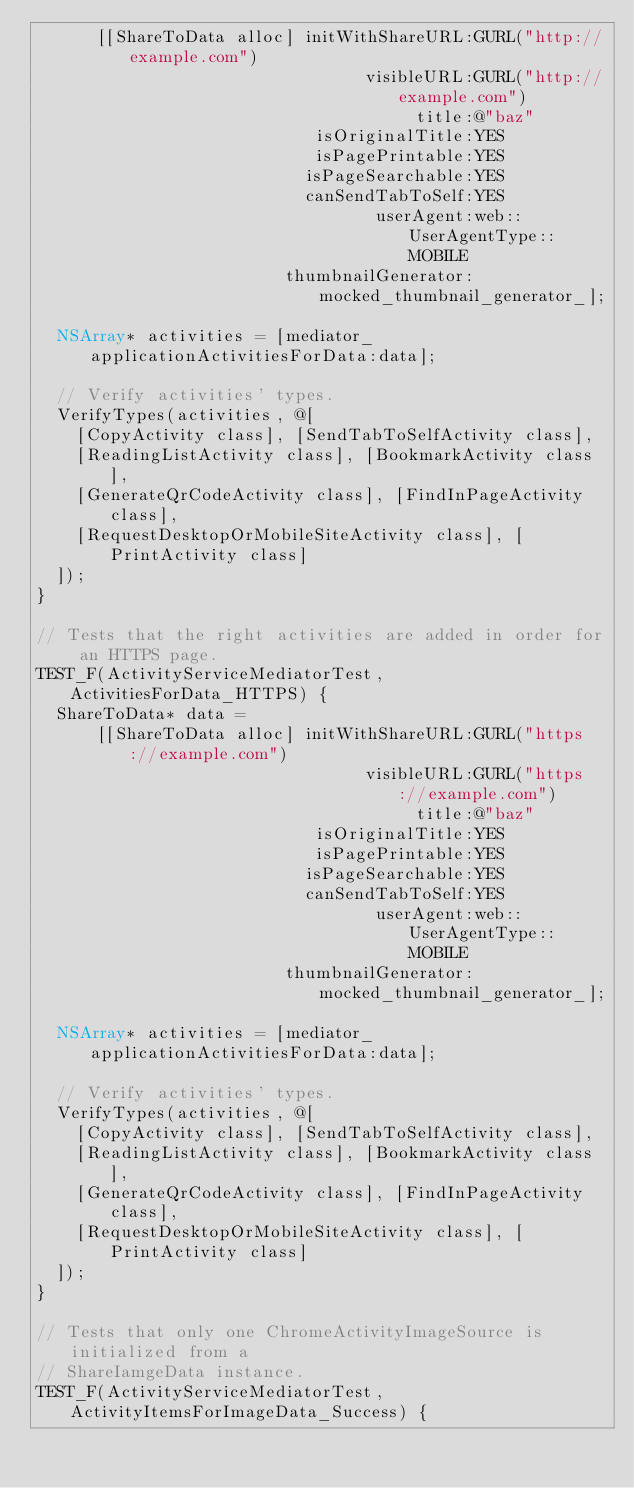Convert code to text. <code><loc_0><loc_0><loc_500><loc_500><_ObjectiveC_>      [[ShareToData alloc] initWithShareURL:GURL("http://example.com")
                                 visibleURL:GURL("http://example.com")
                                      title:@"baz"
                            isOriginalTitle:YES
                            isPagePrintable:YES
                           isPageSearchable:YES
                           canSendTabToSelf:YES
                                  userAgent:web::UserAgentType::MOBILE
                         thumbnailGenerator:mocked_thumbnail_generator_];

  NSArray* activities = [mediator_ applicationActivitiesForData:data];

  // Verify activities' types.
  VerifyTypes(activities, @[
    [CopyActivity class], [SendTabToSelfActivity class],
    [ReadingListActivity class], [BookmarkActivity class],
    [GenerateQrCodeActivity class], [FindInPageActivity class],
    [RequestDesktopOrMobileSiteActivity class], [PrintActivity class]
  ]);
}

// Tests that the right activities are added in order for an HTTPS page.
TEST_F(ActivityServiceMediatorTest, ActivitiesForData_HTTPS) {
  ShareToData* data =
      [[ShareToData alloc] initWithShareURL:GURL("https://example.com")
                                 visibleURL:GURL("https://example.com")
                                      title:@"baz"
                            isOriginalTitle:YES
                            isPagePrintable:YES
                           isPageSearchable:YES
                           canSendTabToSelf:YES
                                  userAgent:web::UserAgentType::MOBILE
                         thumbnailGenerator:mocked_thumbnail_generator_];

  NSArray* activities = [mediator_ applicationActivitiesForData:data];

  // Verify activities' types.
  VerifyTypes(activities, @[
    [CopyActivity class], [SendTabToSelfActivity class],
    [ReadingListActivity class], [BookmarkActivity class],
    [GenerateQrCodeActivity class], [FindInPageActivity class],
    [RequestDesktopOrMobileSiteActivity class], [PrintActivity class]
  ]);
}

// Tests that only one ChromeActivityImageSource is initialized from a
// ShareIamgeData instance.
TEST_F(ActivityServiceMediatorTest, ActivityItemsForImageData_Success) {</code> 